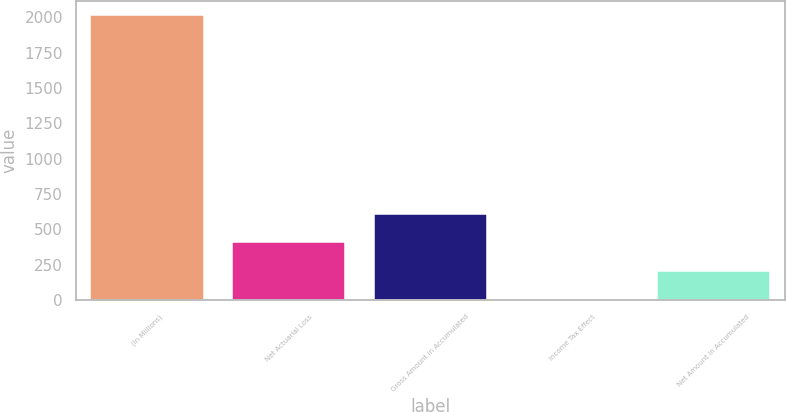Convert chart. <chart><loc_0><loc_0><loc_500><loc_500><bar_chart><fcel>(In Millions)<fcel>Net Actuarial Loss<fcel>Gross Amount in Accumulated<fcel>Income Tax Effect<fcel>Net Amount in Accumulated<nl><fcel>2016<fcel>408.56<fcel>609.49<fcel>6.7<fcel>207.63<nl></chart> 